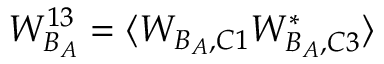Convert formula to latex. <formula><loc_0><loc_0><loc_500><loc_500>W _ { B _ { A } } ^ { 1 3 } = \langle W _ { B _ { A } , C 1 } W _ { B _ { A } , C 3 } ^ { * } \rangle</formula> 